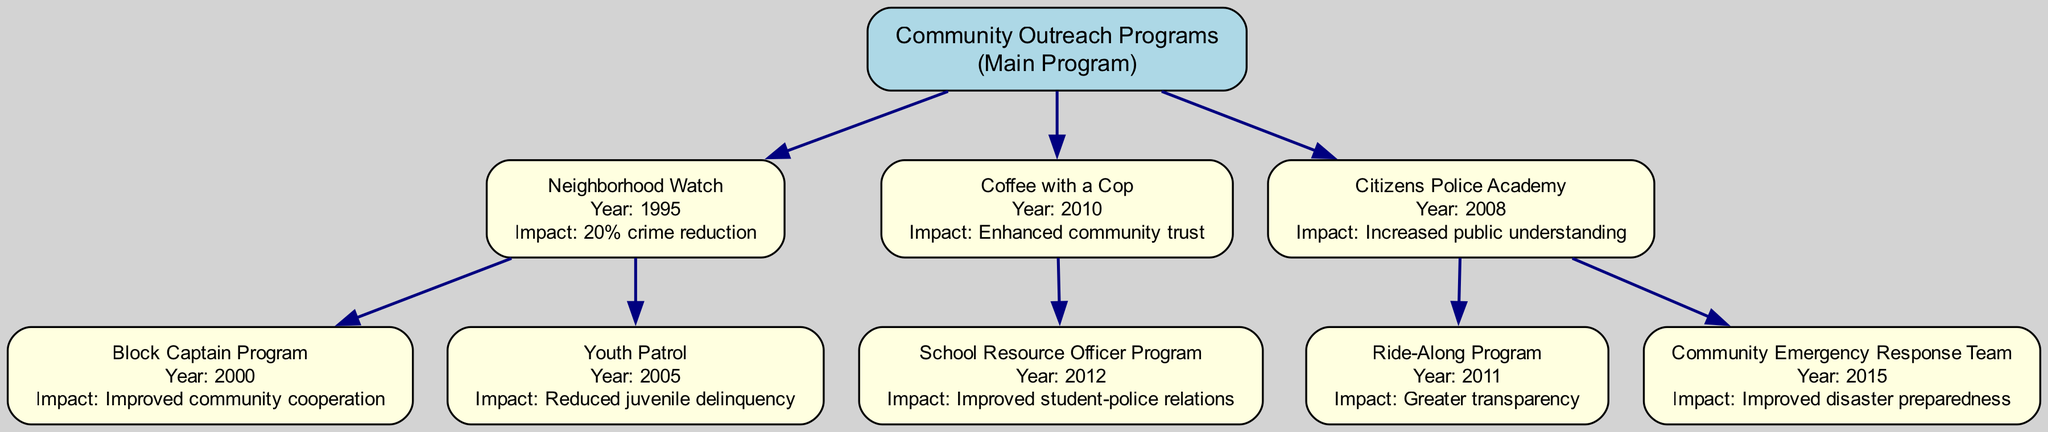What is the main program in the family tree? The main program is at the root of the tree, labeled as "Community Outreach Programs." This serves as the overarching category for all initiatives listed below it.
Answer: Community Outreach Programs In what year was the Youth Patrol program initiated? To find the year of the Youth Patrol program, we look for its parent program, Neighborhood Watch, which was started in 1995, and Youth Patrol is listed as a child of that program, started in 2005.
Answer: 2005 Which program resulted in a 20% crime reduction? The program labeled with a 20% crime reduction is Neighborhood Watch. This information is directly linked to its node in the diagram.
Answer: Neighborhood Watch How many programs are initiated after 2010? By inspecting the diagram, we find the programs initiated after 2010 are Coffee with a Cop (2010), School Resource Officer Program (2012), Ride-Along Program (2011), and Community Emergency Response Team (2015). Counting these, we find there are four.
Answer: 4 What impact did the Citizens Police Academy have? We locate the Citizens Police Academy node and read the impact listed there, which states it has "Increased public understanding." This summarizes its primary effect as conveyed in the diagram.
Answer: Increased public understanding Which program is associated with disaster preparedness? The program connected with improved disaster preparedness, as shown in the diagram, is the Community Emergency Response Team. This is a child node under the Citizens Police Academy program.
Answer: Community Emergency Response Team How many children does the Coffee with a Cop program have? The Coffee with a Cop program has one child node under it, which is the School Resource Officer Program. This can be confirmed by counting the children attached to the Coffee with a Cop node.
Answer: 1 Which outreach program started in 2012? To identify the program that began in 2012, we can check the nodes sequentially and find that the School Resource Officer Program is noted as starting in that particular year.
Answer: School Resource Officer Program What is the impact of the Block Captain Program? The impact of the Block Captain Program is directly mentioned next to its node as "Improved community cooperation." This gives a clear indication of its goal.
Answer: Improved community cooperation 